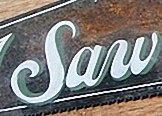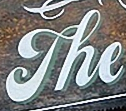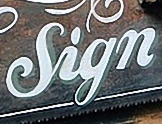What words can you see in these images in sequence, separated by a semicolon? Saw; The; Sign 